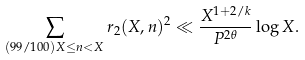<formula> <loc_0><loc_0><loc_500><loc_500>\sum _ { ( 9 9 / 1 0 0 ) X \leq n < X } r _ { 2 } ( X , n ) ^ { 2 } \ll \frac { X ^ { 1 + 2 / k } } { P ^ { 2 \theta } } \log X .</formula> 